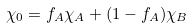Convert formula to latex. <formula><loc_0><loc_0><loc_500><loc_500>\chi _ { 0 } = f _ { A } \chi _ { A } + ( 1 - f _ { A } ) \chi _ { B }</formula> 